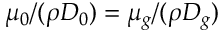Convert formula to latex. <formula><loc_0><loc_0><loc_500><loc_500>\mu _ { 0 } / ( \rho D _ { 0 } ) = \mu _ { g } / ( \rho D _ { g } )</formula> 